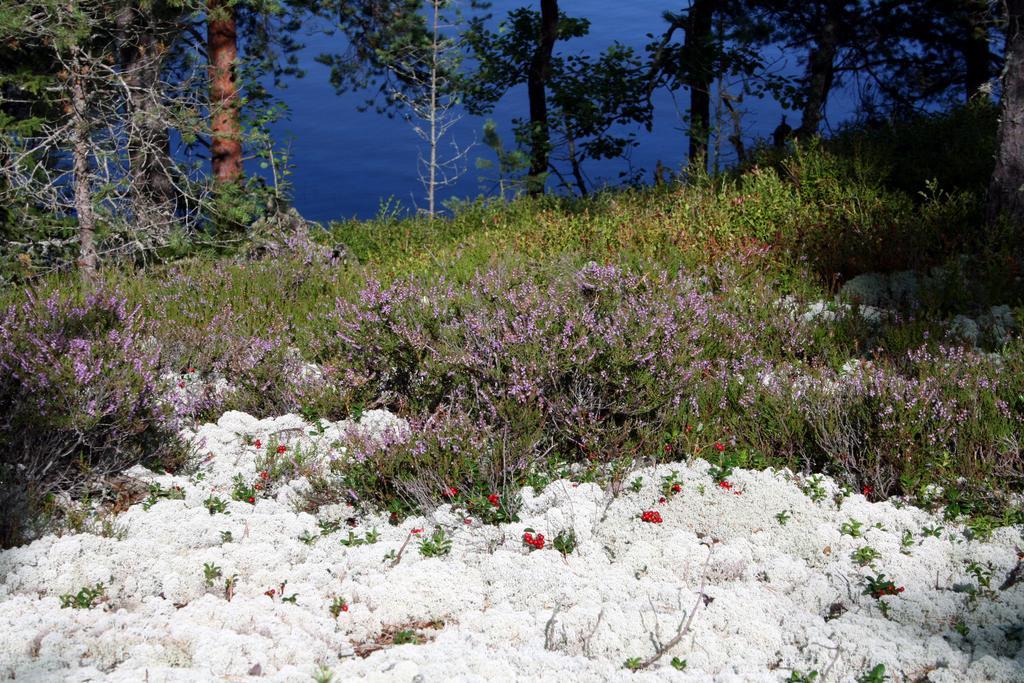In one or two sentences, can you explain what this image depicts? In this image we can see plants and flowers, beside that we can see some fruits. And at the bottom we can see an object which looks like cotton. And at the top we can see trees, beside that we can see water. 